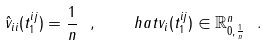Convert formula to latex. <formula><loc_0><loc_0><loc_500><loc_500>\hat { v } _ { i i } ( t ^ { i j } _ { 1 } ) = \frac { 1 } { n } \ , \quad h a t { v } _ { i } ( t ^ { i j } _ { 1 } ) \in \mathbb { R } ^ { n } _ { 0 , \frac { 1 } { n } } \ .</formula> 